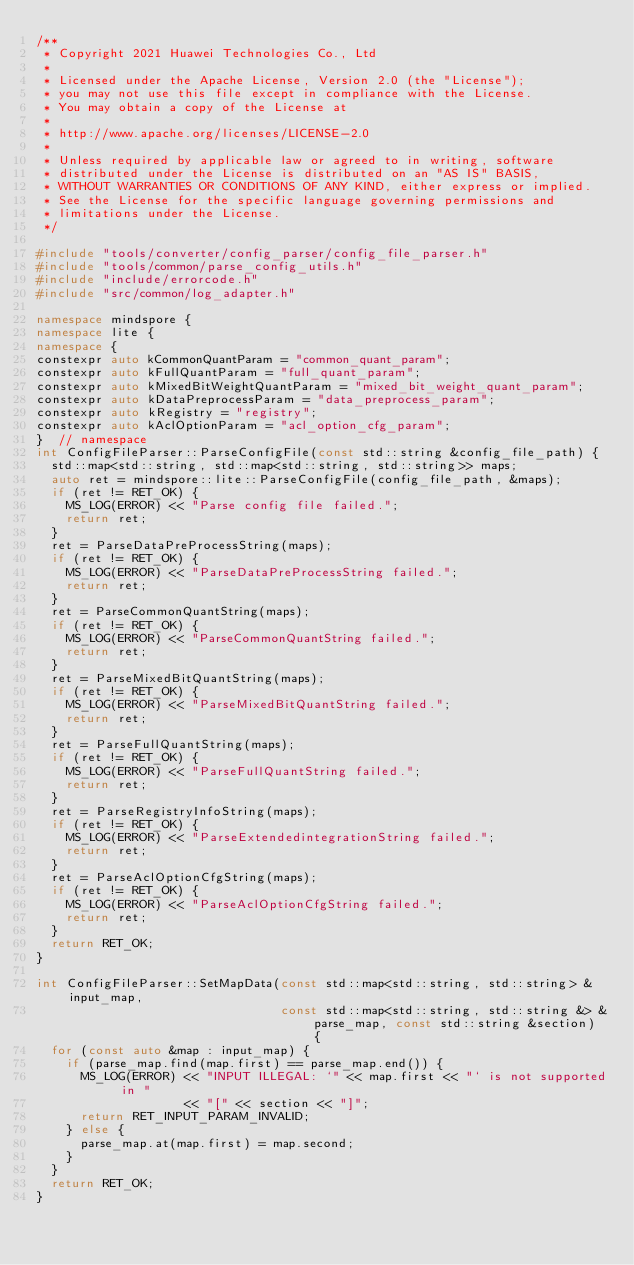<code> <loc_0><loc_0><loc_500><loc_500><_C++_>/**
 * Copyright 2021 Huawei Technologies Co., Ltd
 *
 * Licensed under the Apache License, Version 2.0 (the "License");
 * you may not use this file except in compliance with the License.
 * You may obtain a copy of the License at
 *
 * http://www.apache.org/licenses/LICENSE-2.0
 *
 * Unless required by applicable law or agreed to in writing, software
 * distributed under the License is distributed on an "AS IS" BASIS,
 * WITHOUT WARRANTIES OR CONDITIONS OF ANY KIND, either express or implied.
 * See the License for the specific language governing permissions and
 * limitations under the License.
 */

#include "tools/converter/config_parser/config_file_parser.h"
#include "tools/common/parse_config_utils.h"
#include "include/errorcode.h"
#include "src/common/log_adapter.h"

namespace mindspore {
namespace lite {
namespace {
constexpr auto kCommonQuantParam = "common_quant_param";
constexpr auto kFullQuantParam = "full_quant_param";
constexpr auto kMixedBitWeightQuantParam = "mixed_bit_weight_quant_param";
constexpr auto kDataPreprocessParam = "data_preprocess_param";
constexpr auto kRegistry = "registry";
constexpr auto kAclOptionParam = "acl_option_cfg_param";
}  // namespace
int ConfigFileParser::ParseConfigFile(const std::string &config_file_path) {
  std::map<std::string, std::map<std::string, std::string>> maps;
  auto ret = mindspore::lite::ParseConfigFile(config_file_path, &maps);
  if (ret != RET_OK) {
    MS_LOG(ERROR) << "Parse config file failed.";
    return ret;
  }
  ret = ParseDataPreProcessString(maps);
  if (ret != RET_OK) {
    MS_LOG(ERROR) << "ParseDataPreProcessString failed.";
    return ret;
  }
  ret = ParseCommonQuantString(maps);
  if (ret != RET_OK) {
    MS_LOG(ERROR) << "ParseCommonQuantString failed.";
    return ret;
  }
  ret = ParseMixedBitQuantString(maps);
  if (ret != RET_OK) {
    MS_LOG(ERROR) << "ParseMixedBitQuantString failed.";
    return ret;
  }
  ret = ParseFullQuantString(maps);
  if (ret != RET_OK) {
    MS_LOG(ERROR) << "ParseFullQuantString failed.";
    return ret;
  }
  ret = ParseRegistryInfoString(maps);
  if (ret != RET_OK) {
    MS_LOG(ERROR) << "ParseExtendedintegrationString failed.";
    return ret;
  }
  ret = ParseAclOptionCfgString(maps);
  if (ret != RET_OK) {
    MS_LOG(ERROR) << "ParseAclOptionCfgString failed.";
    return ret;
  }
  return RET_OK;
}

int ConfigFileParser::SetMapData(const std::map<std::string, std::string> &input_map,
                                 const std::map<std::string, std::string &> &parse_map, const std::string &section) {
  for (const auto &map : input_map) {
    if (parse_map.find(map.first) == parse_map.end()) {
      MS_LOG(ERROR) << "INPUT ILLEGAL: `" << map.first << "` is not supported in "
                    << "[" << section << "]";
      return RET_INPUT_PARAM_INVALID;
    } else {
      parse_map.at(map.first) = map.second;
    }
  }
  return RET_OK;
}
</code> 